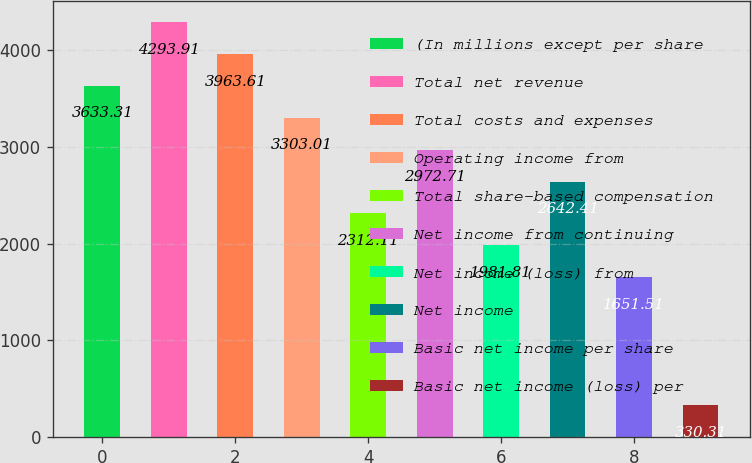Convert chart. <chart><loc_0><loc_0><loc_500><loc_500><bar_chart><fcel>(In millions except per share<fcel>Total net revenue<fcel>Total costs and expenses<fcel>Operating income from<fcel>Total share-based compensation<fcel>Net income from continuing<fcel>Net income (loss) from<fcel>Net income<fcel>Basic net income per share<fcel>Basic net income (loss) per<nl><fcel>3633.31<fcel>4293.91<fcel>3963.61<fcel>3303.01<fcel>2312.11<fcel>2972.71<fcel>1981.81<fcel>2642.41<fcel>1651.51<fcel>330.31<nl></chart> 